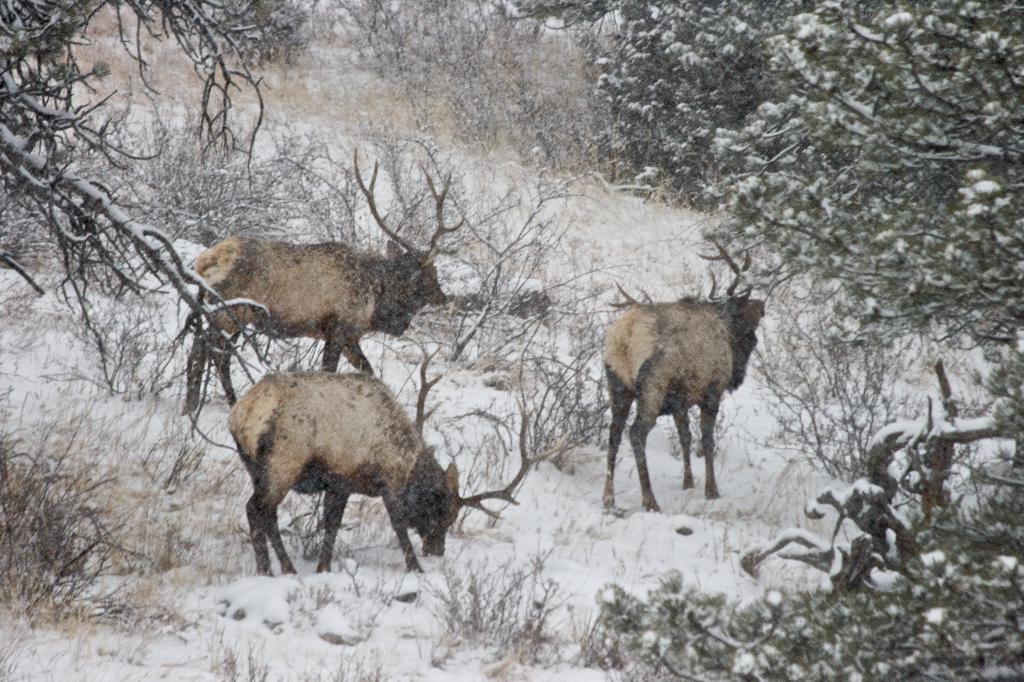Can you describe this image briefly? In this image we can see many trees and plants. There are three animals and a snow in the image. 